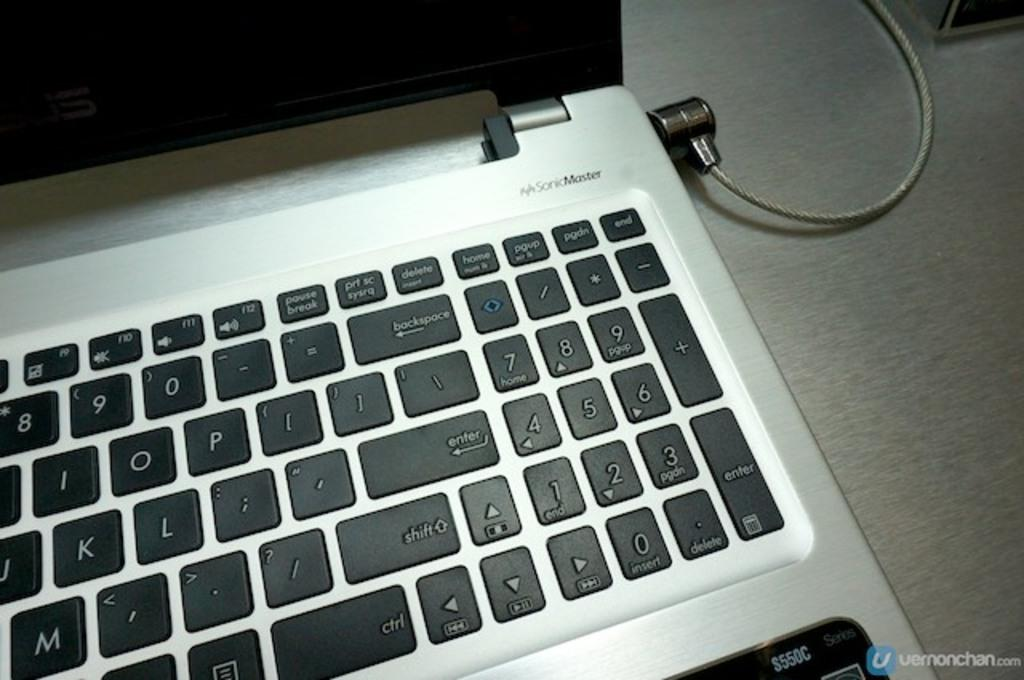What is the color of the surface in the image? The surface in the image is grey colored. What object is placed on the surface? There is a laptop on the surface. What are the colors of the laptop? The laptop is black and grey in color. Is there any connection visible between the laptop and another object? Yes, there is a wire connected to the laptop. Can you see a brush being used by the actor in the image? There is no actor or brush present in the image; it features a grey surface with a black and grey laptop and a wire connected to it. 